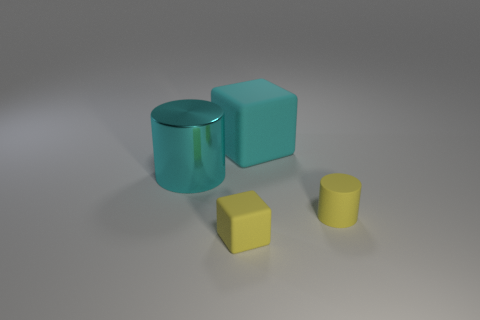There is a rubber thing that is to the right of the cyan matte cube; what number of matte blocks are in front of it?
Your answer should be very brief. 1. What number of other things are there of the same shape as the big rubber thing?
Your response must be concise. 1. What number of objects are metallic cylinders or small things left of the matte cylinder?
Ensure brevity in your answer.  2. Is the number of small yellow things that are to the left of the small yellow cylinder greater than the number of rubber cubes that are to the left of the large metallic cylinder?
Your response must be concise. Yes. There is a yellow thing that is left of the large cyan thing that is behind the cyan thing that is in front of the cyan matte thing; what is its shape?
Provide a short and direct response. Cube. There is a small yellow matte thing that is behind the tiny yellow object that is to the left of the tiny yellow cylinder; what shape is it?
Keep it short and to the point. Cylinder. Is there another big cyan block made of the same material as the large cyan cube?
Your answer should be very brief. No. What is the size of the matte thing that is the same color as the big cylinder?
Your answer should be very brief. Large. How many red objects are either big shiny cylinders or big things?
Your response must be concise. 0. Is there a small matte block that has the same color as the shiny cylinder?
Your answer should be compact. No. 